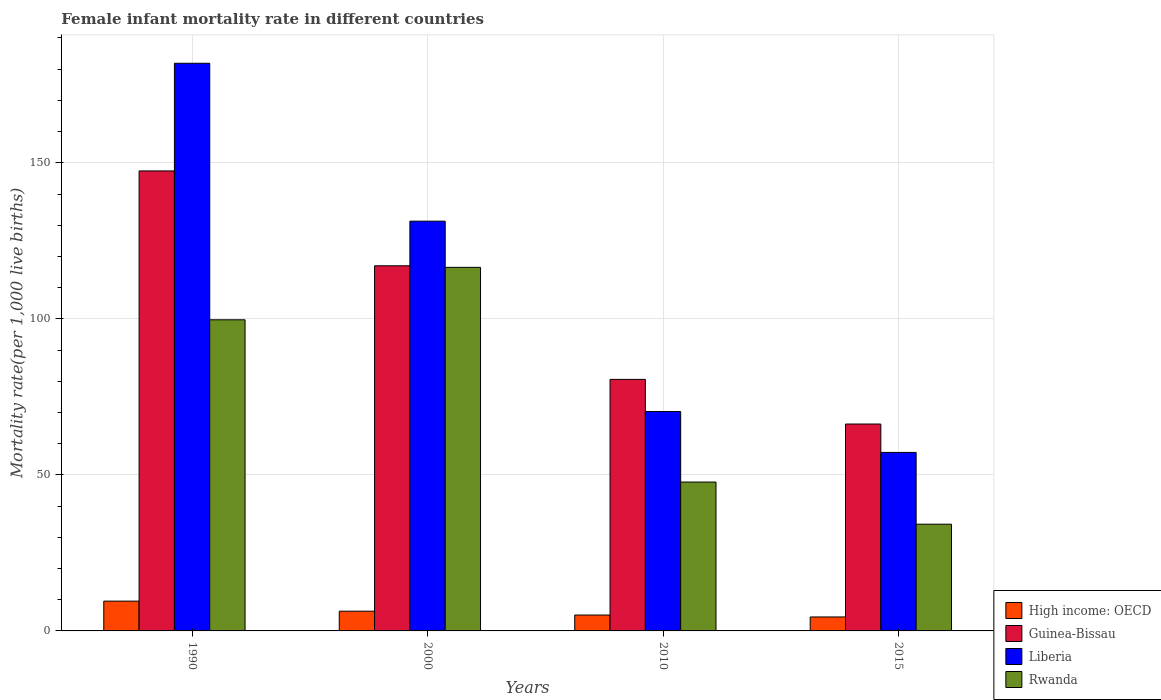How many groups of bars are there?
Provide a short and direct response. 4. Are the number of bars per tick equal to the number of legend labels?
Provide a short and direct response. Yes. How many bars are there on the 1st tick from the right?
Make the answer very short. 4. What is the label of the 4th group of bars from the left?
Ensure brevity in your answer.  2015. In how many cases, is the number of bars for a given year not equal to the number of legend labels?
Ensure brevity in your answer.  0. What is the female infant mortality rate in Liberia in 2015?
Provide a succinct answer. 57.2. Across all years, what is the maximum female infant mortality rate in High income: OECD?
Your answer should be very brief. 9.54. Across all years, what is the minimum female infant mortality rate in Rwanda?
Your answer should be very brief. 34.2. In which year was the female infant mortality rate in Guinea-Bissau maximum?
Offer a very short reply. 1990. In which year was the female infant mortality rate in Rwanda minimum?
Keep it short and to the point. 2015. What is the total female infant mortality rate in Liberia in the graph?
Provide a short and direct response. 440.7. What is the difference between the female infant mortality rate in Guinea-Bissau in 2000 and that in 2015?
Give a very brief answer. 50.7. What is the difference between the female infant mortality rate in Guinea-Bissau in 2000 and the female infant mortality rate in High income: OECD in 2010?
Make the answer very short. 111.91. What is the average female infant mortality rate in Liberia per year?
Offer a very short reply. 110.18. In the year 2015, what is the difference between the female infant mortality rate in Rwanda and female infant mortality rate in Liberia?
Make the answer very short. -23. In how many years, is the female infant mortality rate in Rwanda greater than 110?
Offer a terse response. 1. What is the ratio of the female infant mortality rate in Liberia in 2000 to that in 2015?
Provide a short and direct response. 2.3. What is the difference between the highest and the second highest female infant mortality rate in Guinea-Bissau?
Ensure brevity in your answer.  30.4. What is the difference between the highest and the lowest female infant mortality rate in Guinea-Bissau?
Give a very brief answer. 81.1. Is it the case that in every year, the sum of the female infant mortality rate in Guinea-Bissau and female infant mortality rate in Rwanda is greater than the sum of female infant mortality rate in Liberia and female infant mortality rate in High income: OECD?
Your response must be concise. No. What does the 4th bar from the left in 2010 represents?
Ensure brevity in your answer.  Rwanda. What does the 3rd bar from the right in 1990 represents?
Provide a short and direct response. Guinea-Bissau. Are all the bars in the graph horizontal?
Ensure brevity in your answer.  No. Does the graph contain any zero values?
Offer a terse response. No. Does the graph contain grids?
Offer a very short reply. Yes. Where does the legend appear in the graph?
Offer a very short reply. Bottom right. How many legend labels are there?
Give a very brief answer. 4. What is the title of the graph?
Make the answer very short. Female infant mortality rate in different countries. What is the label or title of the X-axis?
Offer a terse response. Years. What is the label or title of the Y-axis?
Offer a terse response. Mortality rate(per 1,0 live births). What is the Mortality rate(per 1,000 live births) in High income: OECD in 1990?
Give a very brief answer. 9.54. What is the Mortality rate(per 1,000 live births) of Guinea-Bissau in 1990?
Give a very brief answer. 147.4. What is the Mortality rate(per 1,000 live births) of Liberia in 1990?
Your answer should be very brief. 181.9. What is the Mortality rate(per 1,000 live births) in Rwanda in 1990?
Make the answer very short. 99.7. What is the Mortality rate(per 1,000 live births) in High income: OECD in 2000?
Your answer should be compact. 6.32. What is the Mortality rate(per 1,000 live births) in Guinea-Bissau in 2000?
Provide a succinct answer. 117. What is the Mortality rate(per 1,000 live births) of Liberia in 2000?
Offer a terse response. 131.3. What is the Mortality rate(per 1,000 live births) of Rwanda in 2000?
Your response must be concise. 116.5. What is the Mortality rate(per 1,000 live births) in High income: OECD in 2010?
Provide a succinct answer. 5.09. What is the Mortality rate(per 1,000 live births) in Guinea-Bissau in 2010?
Make the answer very short. 80.6. What is the Mortality rate(per 1,000 live births) in Liberia in 2010?
Your response must be concise. 70.3. What is the Mortality rate(per 1,000 live births) of Rwanda in 2010?
Make the answer very short. 47.7. What is the Mortality rate(per 1,000 live births) in High income: OECD in 2015?
Your answer should be very brief. 4.47. What is the Mortality rate(per 1,000 live births) in Guinea-Bissau in 2015?
Give a very brief answer. 66.3. What is the Mortality rate(per 1,000 live births) in Liberia in 2015?
Ensure brevity in your answer.  57.2. What is the Mortality rate(per 1,000 live births) of Rwanda in 2015?
Provide a succinct answer. 34.2. Across all years, what is the maximum Mortality rate(per 1,000 live births) in High income: OECD?
Offer a terse response. 9.54. Across all years, what is the maximum Mortality rate(per 1,000 live births) in Guinea-Bissau?
Your answer should be very brief. 147.4. Across all years, what is the maximum Mortality rate(per 1,000 live births) in Liberia?
Your answer should be compact. 181.9. Across all years, what is the maximum Mortality rate(per 1,000 live births) in Rwanda?
Offer a terse response. 116.5. Across all years, what is the minimum Mortality rate(per 1,000 live births) of High income: OECD?
Your response must be concise. 4.47. Across all years, what is the minimum Mortality rate(per 1,000 live births) in Guinea-Bissau?
Give a very brief answer. 66.3. Across all years, what is the minimum Mortality rate(per 1,000 live births) of Liberia?
Keep it short and to the point. 57.2. Across all years, what is the minimum Mortality rate(per 1,000 live births) in Rwanda?
Your response must be concise. 34.2. What is the total Mortality rate(per 1,000 live births) in High income: OECD in the graph?
Provide a short and direct response. 25.42. What is the total Mortality rate(per 1,000 live births) of Guinea-Bissau in the graph?
Make the answer very short. 411.3. What is the total Mortality rate(per 1,000 live births) in Liberia in the graph?
Give a very brief answer. 440.7. What is the total Mortality rate(per 1,000 live births) of Rwanda in the graph?
Give a very brief answer. 298.1. What is the difference between the Mortality rate(per 1,000 live births) in High income: OECD in 1990 and that in 2000?
Your answer should be very brief. 3.22. What is the difference between the Mortality rate(per 1,000 live births) in Guinea-Bissau in 1990 and that in 2000?
Ensure brevity in your answer.  30.4. What is the difference between the Mortality rate(per 1,000 live births) in Liberia in 1990 and that in 2000?
Keep it short and to the point. 50.6. What is the difference between the Mortality rate(per 1,000 live births) in Rwanda in 1990 and that in 2000?
Offer a terse response. -16.8. What is the difference between the Mortality rate(per 1,000 live births) in High income: OECD in 1990 and that in 2010?
Provide a succinct answer. 4.45. What is the difference between the Mortality rate(per 1,000 live births) of Guinea-Bissau in 1990 and that in 2010?
Your answer should be compact. 66.8. What is the difference between the Mortality rate(per 1,000 live births) in Liberia in 1990 and that in 2010?
Keep it short and to the point. 111.6. What is the difference between the Mortality rate(per 1,000 live births) of High income: OECD in 1990 and that in 2015?
Keep it short and to the point. 5.07. What is the difference between the Mortality rate(per 1,000 live births) of Guinea-Bissau in 1990 and that in 2015?
Give a very brief answer. 81.1. What is the difference between the Mortality rate(per 1,000 live births) in Liberia in 1990 and that in 2015?
Keep it short and to the point. 124.7. What is the difference between the Mortality rate(per 1,000 live births) in Rwanda in 1990 and that in 2015?
Provide a short and direct response. 65.5. What is the difference between the Mortality rate(per 1,000 live births) of High income: OECD in 2000 and that in 2010?
Ensure brevity in your answer.  1.23. What is the difference between the Mortality rate(per 1,000 live births) of Guinea-Bissau in 2000 and that in 2010?
Provide a short and direct response. 36.4. What is the difference between the Mortality rate(per 1,000 live births) in Liberia in 2000 and that in 2010?
Keep it short and to the point. 61. What is the difference between the Mortality rate(per 1,000 live births) in Rwanda in 2000 and that in 2010?
Provide a short and direct response. 68.8. What is the difference between the Mortality rate(per 1,000 live births) of High income: OECD in 2000 and that in 2015?
Offer a terse response. 1.85. What is the difference between the Mortality rate(per 1,000 live births) in Guinea-Bissau in 2000 and that in 2015?
Ensure brevity in your answer.  50.7. What is the difference between the Mortality rate(per 1,000 live births) in Liberia in 2000 and that in 2015?
Keep it short and to the point. 74.1. What is the difference between the Mortality rate(per 1,000 live births) in Rwanda in 2000 and that in 2015?
Your answer should be compact. 82.3. What is the difference between the Mortality rate(per 1,000 live births) of High income: OECD in 2010 and that in 2015?
Provide a succinct answer. 0.62. What is the difference between the Mortality rate(per 1,000 live births) of Guinea-Bissau in 2010 and that in 2015?
Your answer should be compact. 14.3. What is the difference between the Mortality rate(per 1,000 live births) in Liberia in 2010 and that in 2015?
Keep it short and to the point. 13.1. What is the difference between the Mortality rate(per 1,000 live births) in High income: OECD in 1990 and the Mortality rate(per 1,000 live births) in Guinea-Bissau in 2000?
Offer a terse response. -107.46. What is the difference between the Mortality rate(per 1,000 live births) in High income: OECD in 1990 and the Mortality rate(per 1,000 live births) in Liberia in 2000?
Keep it short and to the point. -121.76. What is the difference between the Mortality rate(per 1,000 live births) in High income: OECD in 1990 and the Mortality rate(per 1,000 live births) in Rwanda in 2000?
Provide a succinct answer. -106.96. What is the difference between the Mortality rate(per 1,000 live births) of Guinea-Bissau in 1990 and the Mortality rate(per 1,000 live births) of Rwanda in 2000?
Make the answer very short. 30.9. What is the difference between the Mortality rate(per 1,000 live births) in Liberia in 1990 and the Mortality rate(per 1,000 live births) in Rwanda in 2000?
Your answer should be very brief. 65.4. What is the difference between the Mortality rate(per 1,000 live births) in High income: OECD in 1990 and the Mortality rate(per 1,000 live births) in Guinea-Bissau in 2010?
Offer a very short reply. -71.06. What is the difference between the Mortality rate(per 1,000 live births) in High income: OECD in 1990 and the Mortality rate(per 1,000 live births) in Liberia in 2010?
Provide a short and direct response. -60.76. What is the difference between the Mortality rate(per 1,000 live births) of High income: OECD in 1990 and the Mortality rate(per 1,000 live births) of Rwanda in 2010?
Keep it short and to the point. -38.16. What is the difference between the Mortality rate(per 1,000 live births) of Guinea-Bissau in 1990 and the Mortality rate(per 1,000 live births) of Liberia in 2010?
Keep it short and to the point. 77.1. What is the difference between the Mortality rate(per 1,000 live births) of Guinea-Bissau in 1990 and the Mortality rate(per 1,000 live births) of Rwanda in 2010?
Your answer should be compact. 99.7. What is the difference between the Mortality rate(per 1,000 live births) in Liberia in 1990 and the Mortality rate(per 1,000 live births) in Rwanda in 2010?
Offer a terse response. 134.2. What is the difference between the Mortality rate(per 1,000 live births) in High income: OECD in 1990 and the Mortality rate(per 1,000 live births) in Guinea-Bissau in 2015?
Your answer should be very brief. -56.76. What is the difference between the Mortality rate(per 1,000 live births) of High income: OECD in 1990 and the Mortality rate(per 1,000 live births) of Liberia in 2015?
Give a very brief answer. -47.66. What is the difference between the Mortality rate(per 1,000 live births) of High income: OECD in 1990 and the Mortality rate(per 1,000 live births) of Rwanda in 2015?
Your answer should be compact. -24.66. What is the difference between the Mortality rate(per 1,000 live births) in Guinea-Bissau in 1990 and the Mortality rate(per 1,000 live births) in Liberia in 2015?
Offer a very short reply. 90.2. What is the difference between the Mortality rate(per 1,000 live births) of Guinea-Bissau in 1990 and the Mortality rate(per 1,000 live births) of Rwanda in 2015?
Ensure brevity in your answer.  113.2. What is the difference between the Mortality rate(per 1,000 live births) of Liberia in 1990 and the Mortality rate(per 1,000 live births) of Rwanda in 2015?
Provide a succinct answer. 147.7. What is the difference between the Mortality rate(per 1,000 live births) in High income: OECD in 2000 and the Mortality rate(per 1,000 live births) in Guinea-Bissau in 2010?
Provide a succinct answer. -74.28. What is the difference between the Mortality rate(per 1,000 live births) in High income: OECD in 2000 and the Mortality rate(per 1,000 live births) in Liberia in 2010?
Make the answer very short. -63.98. What is the difference between the Mortality rate(per 1,000 live births) of High income: OECD in 2000 and the Mortality rate(per 1,000 live births) of Rwanda in 2010?
Give a very brief answer. -41.38. What is the difference between the Mortality rate(per 1,000 live births) in Guinea-Bissau in 2000 and the Mortality rate(per 1,000 live births) in Liberia in 2010?
Provide a short and direct response. 46.7. What is the difference between the Mortality rate(per 1,000 live births) in Guinea-Bissau in 2000 and the Mortality rate(per 1,000 live births) in Rwanda in 2010?
Your answer should be very brief. 69.3. What is the difference between the Mortality rate(per 1,000 live births) of Liberia in 2000 and the Mortality rate(per 1,000 live births) of Rwanda in 2010?
Make the answer very short. 83.6. What is the difference between the Mortality rate(per 1,000 live births) of High income: OECD in 2000 and the Mortality rate(per 1,000 live births) of Guinea-Bissau in 2015?
Offer a terse response. -59.98. What is the difference between the Mortality rate(per 1,000 live births) of High income: OECD in 2000 and the Mortality rate(per 1,000 live births) of Liberia in 2015?
Offer a very short reply. -50.88. What is the difference between the Mortality rate(per 1,000 live births) in High income: OECD in 2000 and the Mortality rate(per 1,000 live births) in Rwanda in 2015?
Offer a very short reply. -27.88. What is the difference between the Mortality rate(per 1,000 live births) of Guinea-Bissau in 2000 and the Mortality rate(per 1,000 live births) of Liberia in 2015?
Give a very brief answer. 59.8. What is the difference between the Mortality rate(per 1,000 live births) of Guinea-Bissau in 2000 and the Mortality rate(per 1,000 live births) of Rwanda in 2015?
Ensure brevity in your answer.  82.8. What is the difference between the Mortality rate(per 1,000 live births) in Liberia in 2000 and the Mortality rate(per 1,000 live births) in Rwanda in 2015?
Provide a succinct answer. 97.1. What is the difference between the Mortality rate(per 1,000 live births) of High income: OECD in 2010 and the Mortality rate(per 1,000 live births) of Guinea-Bissau in 2015?
Provide a succinct answer. -61.21. What is the difference between the Mortality rate(per 1,000 live births) in High income: OECD in 2010 and the Mortality rate(per 1,000 live births) in Liberia in 2015?
Provide a short and direct response. -52.11. What is the difference between the Mortality rate(per 1,000 live births) of High income: OECD in 2010 and the Mortality rate(per 1,000 live births) of Rwanda in 2015?
Keep it short and to the point. -29.11. What is the difference between the Mortality rate(per 1,000 live births) in Guinea-Bissau in 2010 and the Mortality rate(per 1,000 live births) in Liberia in 2015?
Keep it short and to the point. 23.4. What is the difference between the Mortality rate(per 1,000 live births) of Guinea-Bissau in 2010 and the Mortality rate(per 1,000 live births) of Rwanda in 2015?
Provide a short and direct response. 46.4. What is the difference between the Mortality rate(per 1,000 live births) in Liberia in 2010 and the Mortality rate(per 1,000 live births) in Rwanda in 2015?
Offer a terse response. 36.1. What is the average Mortality rate(per 1,000 live births) in High income: OECD per year?
Provide a succinct answer. 6.36. What is the average Mortality rate(per 1,000 live births) of Guinea-Bissau per year?
Keep it short and to the point. 102.83. What is the average Mortality rate(per 1,000 live births) in Liberia per year?
Make the answer very short. 110.17. What is the average Mortality rate(per 1,000 live births) of Rwanda per year?
Ensure brevity in your answer.  74.53. In the year 1990, what is the difference between the Mortality rate(per 1,000 live births) of High income: OECD and Mortality rate(per 1,000 live births) of Guinea-Bissau?
Make the answer very short. -137.86. In the year 1990, what is the difference between the Mortality rate(per 1,000 live births) of High income: OECD and Mortality rate(per 1,000 live births) of Liberia?
Ensure brevity in your answer.  -172.36. In the year 1990, what is the difference between the Mortality rate(per 1,000 live births) in High income: OECD and Mortality rate(per 1,000 live births) in Rwanda?
Keep it short and to the point. -90.16. In the year 1990, what is the difference between the Mortality rate(per 1,000 live births) in Guinea-Bissau and Mortality rate(per 1,000 live births) in Liberia?
Offer a terse response. -34.5. In the year 1990, what is the difference between the Mortality rate(per 1,000 live births) of Guinea-Bissau and Mortality rate(per 1,000 live births) of Rwanda?
Make the answer very short. 47.7. In the year 1990, what is the difference between the Mortality rate(per 1,000 live births) of Liberia and Mortality rate(per 1,000 live births) of Rwanda?
Provide a succinct answer. 82.2. In the year 2000, what is the difference between the Mortality rate(per 1,000 live births) in High income: OECD and Mortality rate(per 1,000 live births) in Guinea-Bissau?
Provide a succinct answer. -110.68. In the year 2000, what is the difference between the Mortality rate(per 1,000 live births) in High income: OECD and Mortality rate(per 1,000 live births) in Liberia?
Provide a succinct answer. -124.98. In the year 2000, what is the difference between the Mortality rate(per 1,000 live births) of High income: OECD and Mortality rate(per 1,000 live births) of Rwanda?
Your response must be concise. -110.18. In the year 2000, what is the difference between the Mortality rate(per 1,000 live births) of Guinea-Bissau and Mortality rate(per 1,000 live births) of Liberia?
Offer a terse response. -14.3. In the year 2010, what is the difference between the Mortality rate(per 1,000 live births) in High income: OECD and Mortality rate(per 1,000 live births) in Guinea-Bissau?
Give a very brief answer. -75.51. In the year 2010, what is the difference between the Mortality rate(per 1,000 live births) of High income: OECD and Mortality rate(per 1,000 live births) of Liberia?
Your response must be concise. -65.21. In the year 2010, what is the difference between the Mortality rate(per 1,000 live births) in High income: OECD and Mortality rate(per 1,000 live births) in Rwanda?
Your answer should be very brief. -42.61. In the year 2010, what is the difference between the Mortality rate(per 1,000 live births) in Guinea-Bissau and Mortality rate(per 1,000 live births) in Liberia?
Provide a short and direct response. 10.3. In the year 2010, what is the difference between the Mortality rate(per 1,000 live births) in Guinea-Bissau and Mortality rate(per 1,000 live births) in Rwanda?
Keep it short and to the point. 32.9. In the year 2010, what is the difference between the Mortality rate(per 1,000 live births) of Liberia and Mortality rate(per 1,000 live births) of Rwanda?
Provide a succinct answer. 22.6. In the year 2015, what is the difference between the Mortality rate(per 1,000 live births) in High income: OECD and Mortality rate(per 1,000 live births) in Guinea-Bissau?
Your response must be concise. -61.83. In the year 2015, what is the difference between the Mortality rate(per 1,000 live births) in High income: OECD and Mortality rate(per 1,000 live births) in Liberia?
Give a very brief answer. -52.73. In the year 2015, what is the difference between the Mortality rate(per 1,000 live births) of High income: OECD and Mortality rate(per 1,000 live births) of Rwanda?
Give a very brief answer. -29.73. In the year 2015, what is the difference between the Mortality rate(per 1,000 live births) in Guinea-Bissau and Mortality rate(per 1,000 live births) in Rwanda?
Keep it short and to the point. 32.1. What is the ratio of the Mortality rate(per 1,000 live births) of High income: OECD in 1990 to that in 2000?
Your response must be concise. 1.51. What is the ratio of the Mortality rate(per 1,000 live births) of Guinea-Bissau in 1990 to that in 2000?
Offer a very short reply. 1.26. What is the ratio of the Mortality rate(per 1,000 live births) in Liberia in 1990 to that in 2000?
Your answer should be very brief. 1.39. What is the ratio of the Mortality rate(per 1,000 live births) in Rwanda in 1990 to that in 2000?
Offer a very short reply. 0.86. What is the ratio of the Mortality rate(per 1,000 live births) of High income: OECD in 1990 to that in 2010?
Give a very brief answer. 1.88. What is the ratio of the Mortality rate(per 1,000 live births) in Guinea-Bissau in 1990 to that in 2010?
Offer a very short reply. 1.83. What is the ratio of the Mortality rate(per 1,000 live births) in Liberia in 1990 to that in 2010?
Keep it short and to the point. 2.59. What is the ratio of the Mortality rate(per 1,000 live births) in Rwanda in 1990 to that in 2010?
Provide a short and direct response. 2.09. What is the ratio of the Mortality rate(per 1,000 live births) of High income: OECD in 1990 to that in 2015?
Provide a succinct answer. 2.13. What is the ratio of the Mortality rate(per 1,000 live births) of Guinea-Bissau in 1990 to that in 2015?
Provide a short and direct response. 2.22. What is the ratio of the Mortality rate(per 1,000 live births) in Liberia in 1990 to that in 2015?
Your answer should be very brief. 3.18. What is the ratio of the Mortality rate(per 1,000 live births) of Rwanda in 1990 to that in 2015?
Provide a succinct answer. 2.92. What is the ratio of the Mortality rate(per 1,000 live births) of High income: OECD in 2000 to that in 2010?
Keep it short and to the point. 1.24. What is the ratio of the Mortality rate(per 1,000 live births) of Guinea-Bissau in 2000 to that in 2010?
Give a very brief answer. 1.45. What is the ratio of the Mortality rate(per 1,000 live births) of Liberia in 2000 to that in 2010?
Make the answer very short. 1.87. What is the ratio of the Mortality rate(per 1,000 live births) in Rwanda in 2000 to that in 2010?
Your answer should be very brief. 2.44. What is the ratio of the Mortality rate(per 1,000 live births) of High income: OECD in 2000 to that in 2015?
Offer a very short reply. 1.41. What is the ratio of the Mortality rate(per 1,000 live births) in Guinea-Bissau in 2000 to that in 2015?
Keep it short and to the point. 1.76. What is the ratio of the Mortality rate(per 1,000 live births) of Liberia in 2000 to that in 2015?
Provide a succinct answer. 2.3. What is the ratio of the Mortality rate(per 1,000 live births) of Rwanda in 2000 to that in 2015?
Offer a very short reply. 3.41. What is the ratio of the Mortality rate(per 1,000 live births) in High income: OECD in 2010 to that in 2015?
Provide a short and direct response. 1.14. What is the ratio of the Mortality rate(per 1,000 live births) in Guinea-Bissau in 2010 to that in 2015?
Offer a very short reply. 1.22. What is the ratio of the Mortality rate(per 1,000 live births) of Liberia in 2010 to that in 2015?
Your response must be concise. 1.23. What is the ratio of the Mortality rate(per 1,000 live births) of Rwanda in 2010 to that in 2015?
Ensure brevity in your answer.  1.39. What is the difference between the highest and the second highest Mortality rate(per 1,000 live births) of High income: OECD?
Offer a very short reply. 3.22. What is the difference between the highest and the second highest Mortality rate(per 1,000 live births) of Guinea-Bissau?
Keep it short and to the point. 30.4. What is the difference between the highest and the second highest Mortality rate(per 1,000 live births) of Liberia?
Provide a short and direct response. 50.6. What is the difference between the highest and the second highest Mortality rate(per 1,000 live births) in Rwanda?
Your answer should be very brief. 16.8. What is the difference between the highest and the lowest Mortality rate(per 1,000 live births) of High income: OECD?
Give a very brief answer. 5.07. What is the difference between the highest and the lowest Mortality rate(per 1,000 live births) of Guinea-Bissau?
Provide a succinct answer. 81.1. What is the difference between the highest and the lowest Mortality rate(per 1,000 live births) in Liberia?
Make the answer very short. 124.7. What is the difference between the highest and the lowest Mortality rate(per 1,000 live births) in Rwanda?
Your response must be concise. 82.3. 